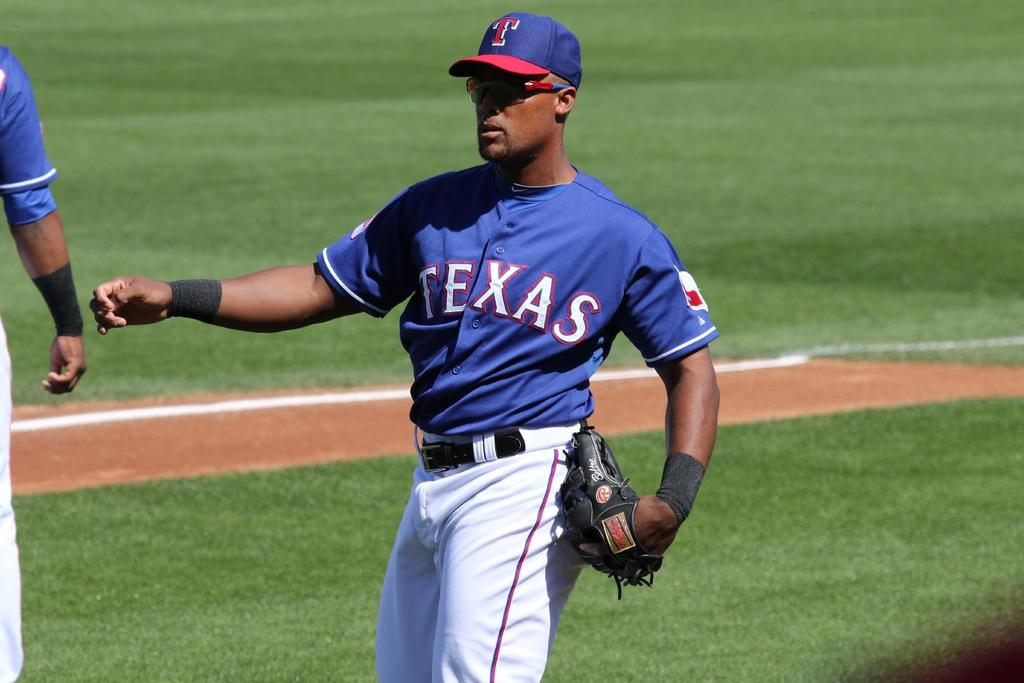<image>
Present a compact description of the photo's key features. The baseball player plays for the Texas team. 